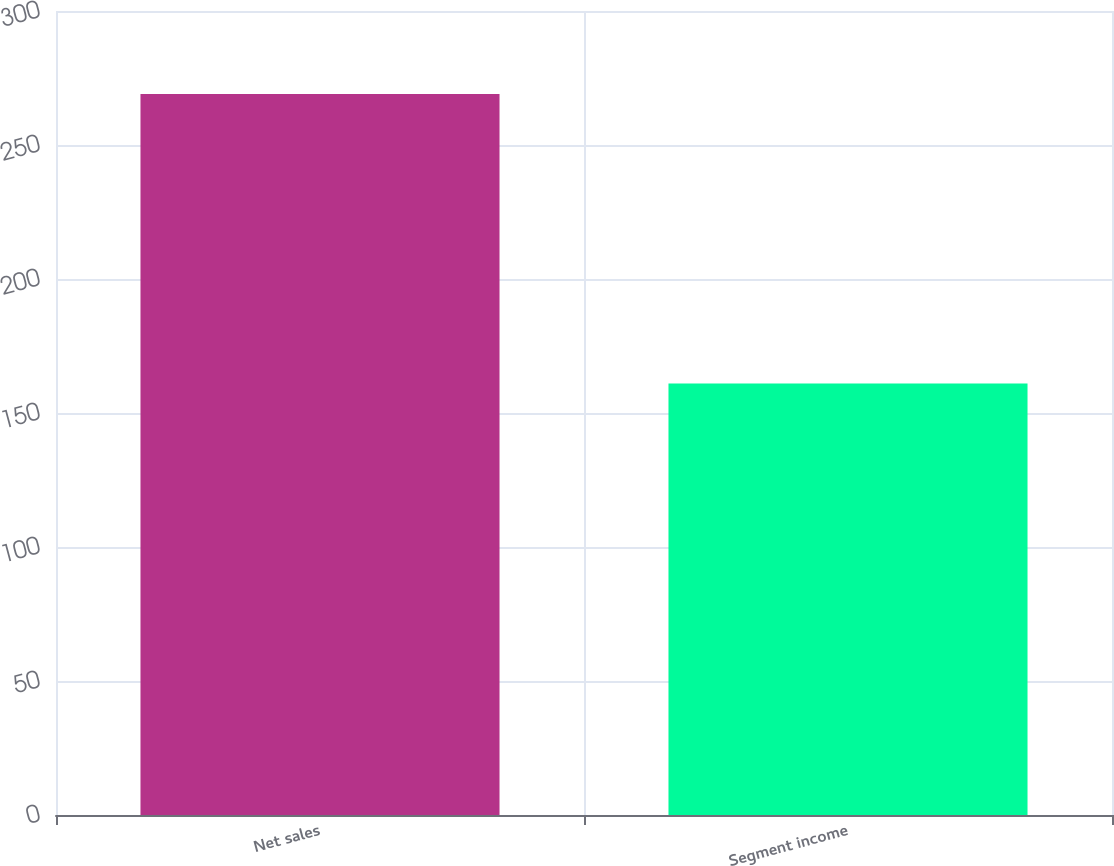<chart> <loc_0><loc_0><loc_500><loc_500><bar_chart><fcel>Net sales<fcel>Segment income<nl><fcel>269<fcel>161<nl></chart> 